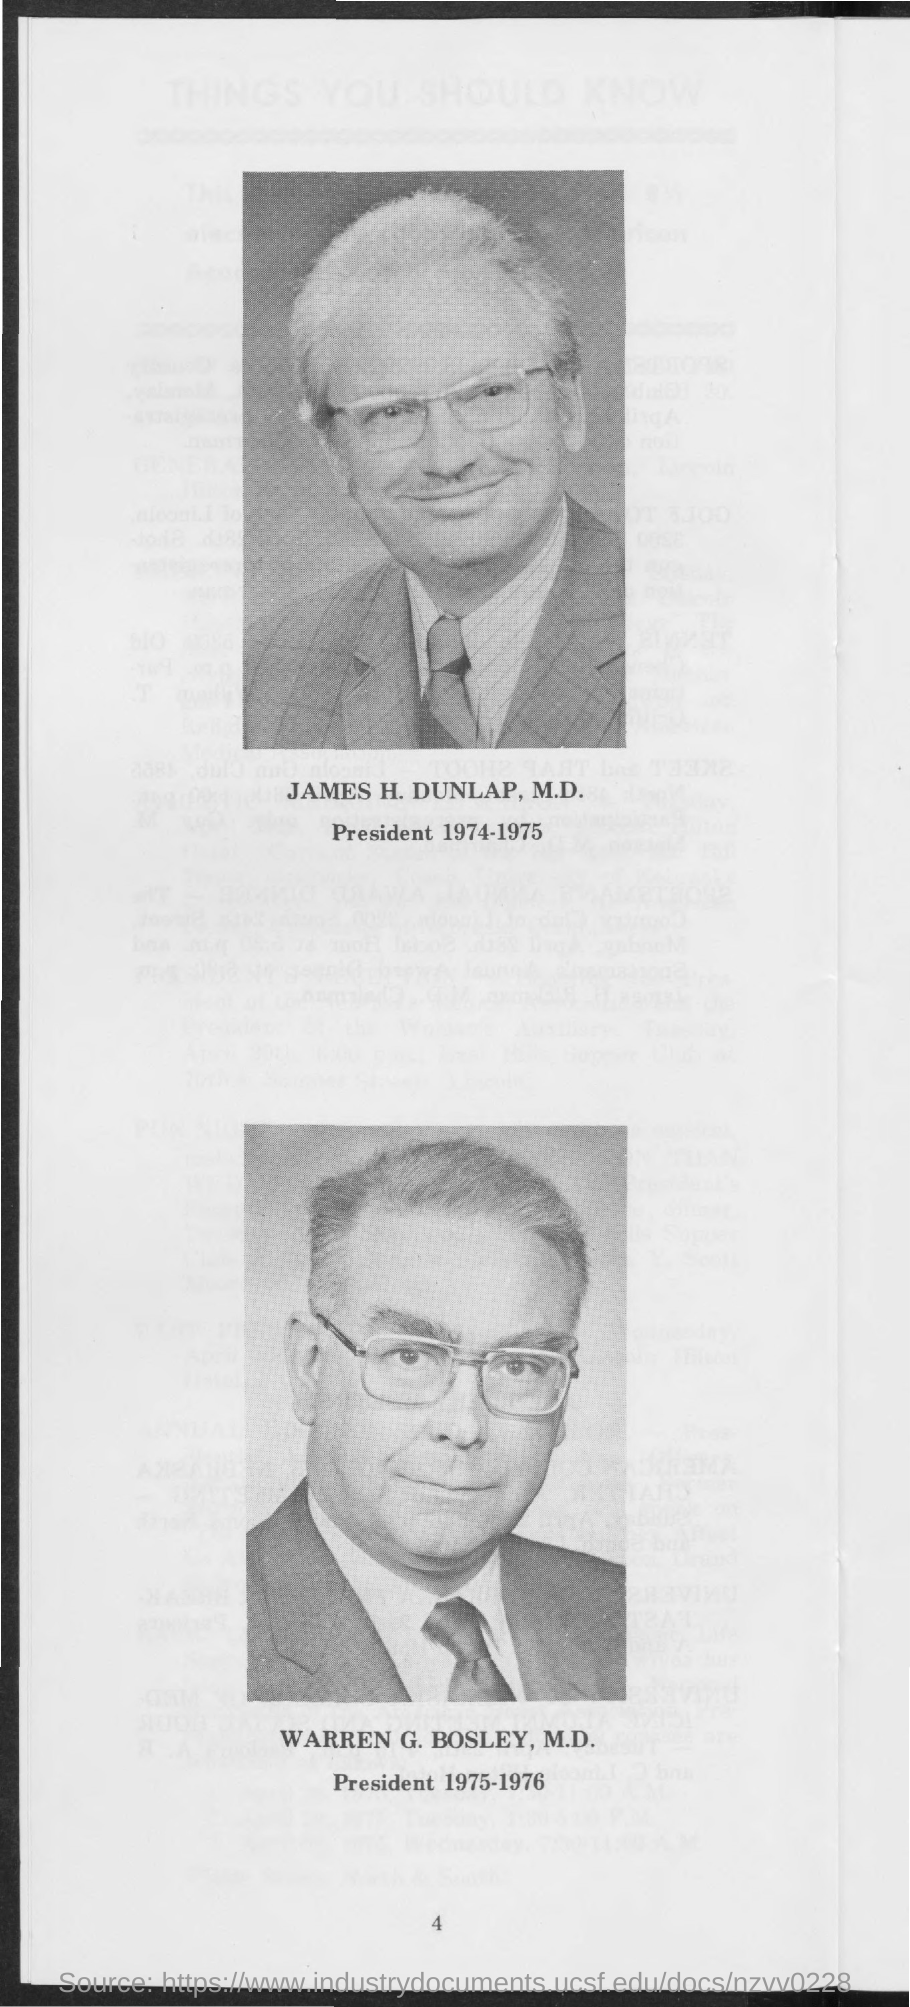Point out several critical features in this image. In the year 1975-1976, Warren G. Bosley, M.D., served as the president. During the years 1974-1975, James H. Dunlap was the president. 